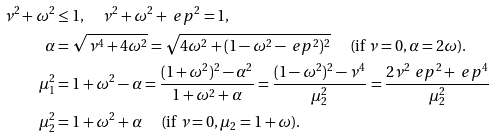<formula> <loc_0><loc_0><loc_500><loc_500>\nu ^ { 2 } + \omega ^ { 2 } & \leq 1 , \quad \nu ^ { 2 } + \omega ^ { 2 } + \ e p ^ { 2 } = 1 , \\ \alpha & = \sqrt { \nu ^ { 4 } + 4 \omega ^ { 2 } } = \sqrt { 4 \omega ^ { 2 } + ( 1 - \omega ^ { 2 } - \ e p ^ { 2 } ) ^ { 2 } } \quad \text {      (if      $\nu=0, \alpha=2\omega$).} \\ \mu _ { 1 } ^ { 2 } & = 1 + \omega ^ { 2 } - \alpha = \frac { ( 1 + \omega ^ { 2 } ) ^ { 2 } - \alpha ^ { 2 } } { 1 + \omega ^ { 2 } + \alpha } = \frac { ( 1 - \omega ^ { 2 } ) ^ { 2 } - \nu ^ { 4 } } { \mu _ { 2 } ^ { 2 } } = \frac { 2 \nu ^ { 2 } \ e p ^ { 2 } + \ e p ^ { 4 } } { \mu _ { 2 } ^ { 2 } } \\ \mu _ { 2 } ^ { 2 } & = 1 + \omega ^ { 2 } + \alpha \quad \text {       (if      $\nu=0, \mu_{2}=1+\omega$).}</formula> 